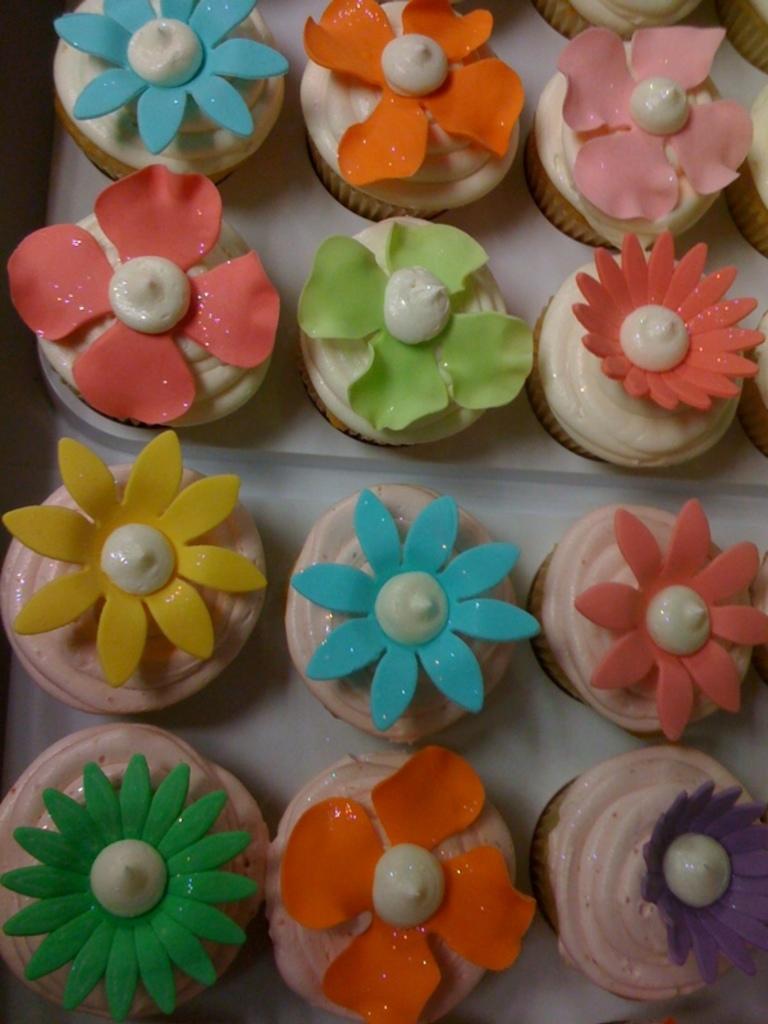In one or two sentences, can you explain what this image depicts? In this picture we can see few cupcakes in the plates. 